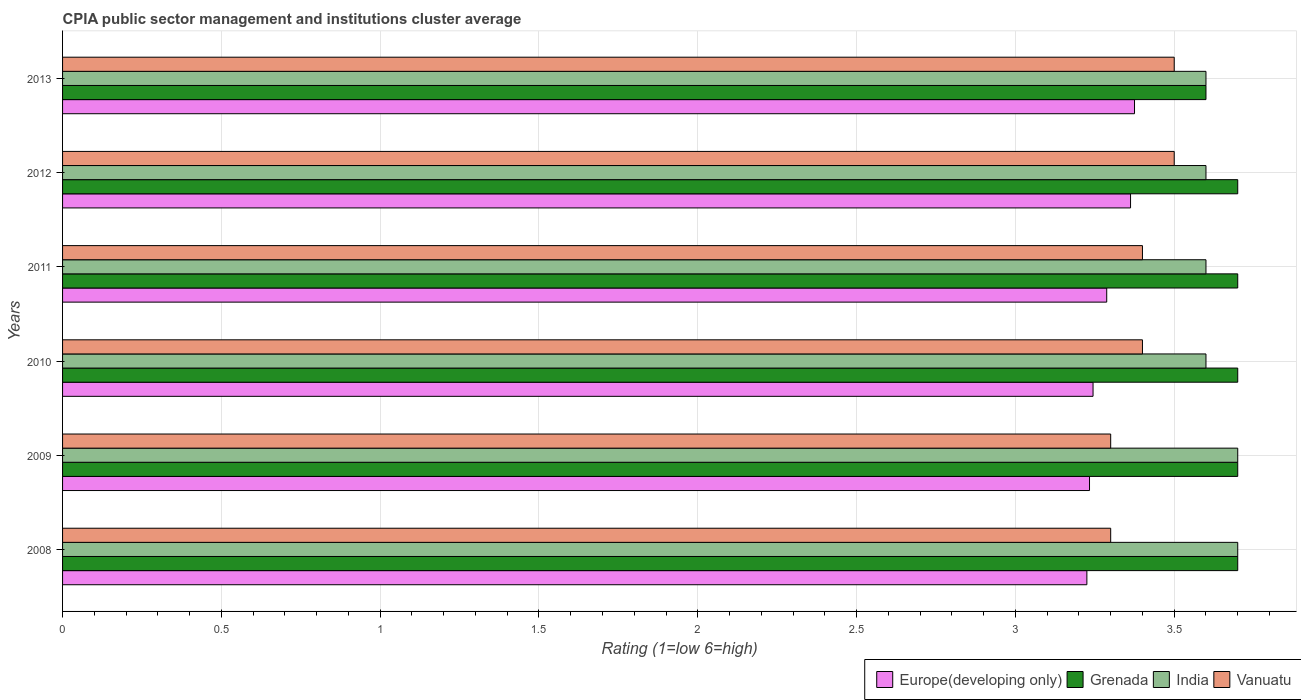How many bars are there on the 5th tick from the top?
Provide a short and direct response. 4. In how many cases, is the number of bars for a given year not equal to the number of legend labels?
Your response must be concise. 0. What is the CPIA rating in Europe(developing only) in 2009?
Make the answer very short. 3.23. What is the total CPIA rating in India in the graph?
Your response must be concise. 21.8. What is the difference between the CPIA rating in Vanuatu in 2012 and that in 2013?
Make the answer very short. 0. What is the difference between the CPIA rating in Vanuatu in 2011 and the CPIA rating in Europe(developing only) in 2012?
Your answer should be compact. 0.04. What is the average CPIA rating in Europe(developing only) per year?
Provide a short and direct response. 3.29. In the year 2011, what is the difference between the CPIA rating in Europe(developing only) and CPIA rating in Vanuatu?
Your answer should be very brief. -0.11. In how many years, is the CPIA rating in Europe(developing only) greater than 2.7 ?
Provide a succinct answer. 6. Is the difference between the CPIA rating in Europe(developing only) in 2008 and 2013 greater than the difference between the CPIA rating in Vanuatu in 2008 and 2013?
Offer a terse response. Yes. What is the difference between the highest and the lowest CPIA rating in Vanuatu?
Your response must be concise. 0.2. In how many years, is the CPIA rating in Grenada greater than the average CPIA rating in Grenada taken over all years?
Your answer should be compact. 5. Is the sum of the CPIA rating in India in 2008 and 2009 greater than the maximum CPIA rating in Europe(developing only) across all years?
Ensure brevity in your answer.  Yes. What does the 4th bar from the top in 2013 represents?
Keep it short and to the point. Europe(developing only). What does the 4th bar from the bottom in 2009 represents?
Make the answer very short. Vanuatu. Are all the bars in the graph horizontal?
Provide a succinct answer. Yes. Are the values on the major ticks of X-axis written in scientific E-notation?
Your response must be concise. No. Does the graph contain grids?
Offer a very short reply. Yes. How many legend labels are there?
Keep it short and to the point. 4. How are the legend labels stacked?
Ensure brevity in your answer.  Horizontal. What is the title of the graph?
Ensure brevity in your answer.  CPIA public sector management and institutions cluster average. Does "Netherlands" appear as one of the legend labels in the graph?
Make the answer very short. No. What is the label or title of the X-axis?
Your answer should be very brief. Rating (1=low 6=high). What is the label or title of the Y-axis?
Provide a short and direct response. Years. What is the Rating (1=low 6=high) of Europe(developing only) in 2008?
Your answer should be very brief. 3.23. What is the Rating (1=low 6=high) in Europe(developing only) in 2009?
Provide a succinct answer. 3.23. What is the Rating (1=low 6=high) of Grenada in 2009?
Keep it short and to the point. 3.7. What is the Rating (1=low 6=high) of Vanuatu in 2009?
Offer a terse response. 3.3. What is the Rating (1=low 6=high) in Europe(developing only) in 2010?
Offer a terse response. 3.24. What is the Rating (1=low 6=high) in India in 2010?
Your response must be concise. 3.6. What is the Rating (1=low 6=high) in Vanuatu in 2010?
Keep it short and to the point. 3.4. What is the Rating (1=low 6=high) in Europe(developing only) in 2011?
Ensure brevity in your answer.  3.29. What is the Rating (1=low 6=high) in Grenada in 2011?
Keep it short and to the point. 3.7. What is the Rating (1=low 6=high) in Europe(developing only) in 2012?
Your answer should be compact. 3.36. What is the Rating (1=low 6=high) of Vanuatu in 2012?
Your answer should be compact. 3.5. What is the Rating (1=low 6=high) in Europe(developing only) in 2013?
Offer a very short reply. 3.38. What is the Rating (1=low 6=high) of India in 2013?
Offer a terse response. 3.6. Across all years, what is the maximum Rating (1=low 6=high) of Europe(developing only)?
Provide a succinct answer. 3.38. Across all years, what is the minimum Rating (1=low 6=high) in Europe(developing only)?
Offer a very short reply. 3.23. What is the total Rating (1=low 6=high) of Europe(developing only) in the graph?
Keep it short and to the point. 19.73. What is the total Rating (1=low 6=high) in Grenada in the graph?
Keep it short and to the point. 22.1. What is the total Rating (1=low 6=high) in India in the graph?
Your answer should be compact. 21.8. What is the total Rating (1=low 6=high) in Vanuatu in the graph?
Provide a short and direct response. 20.4. What is the difference between the Rating (1=low 6=high) of Europe(developing only) in 2008 and that in 2009?
Keep it short and to the point. -0.01. What is the difference between the Rating (1=low 6=high) of Grenada in 2008 and that in 2009?
Your response must be concise. 0. What is the difference between the Rating (1=low 6=high) in India in 2008 and that in 2009?
Make the answer very short. 0. What is the difference between the Rating (1=low 6=high) of Europe(developing only) in 2008 and that in 2010?
Make the answer very short. -0.02. What is the difference between the Rating (1=low 6=high) in Grenada in 2008 and that in 2010?
Provide a succinct answer. 0. What is the difference between the Rating (1=low 6=high) in India in 2008 and that in 2010?
Make the answer very short. 0.1. What is the difference between the Rating (1=low 6=high) of Vanuatu in 2008 and that in 2010?
Offer a terse response. -0.1. What is the difference between the Rating (1=low 6=high) of Europe(developing only) in 2008 and that in 2011?
Ensure brevity in your answer.  -0.06. What is the difference between the Rating (1=low 6=high) in India in 2008 and that in 2011?
Your answer should be very brief. 0.1. What is the difference between the Rating (1=low 6=high) of Europe(developing only) in 2008 and that in 2012?
Keep it short and to the point. -0.14. What is the difference between the Rating (1=low 6=high) in Vanuatu in 2008 and that in 2012?
Keep it short and to the point. -0.2. What is the difference between the Rating (1=low 6=high) in Grenada in 2008 and that in 2013?
Keep it short and to the point. 0.1. What is the difference between the Rating (1=low 6=high) in India in 2008 and that in 2013?
Provide a succinct answer. 0.1. What is the difference between the Rating (1=low 6=high) in Vanuatu in 2008 and that in 2013?
Give a very brief answer. -0.2. What is the difference between the Rating (1=low 6=high) of Europe(developing only) in 2009 and that in 2010?
Offer a terse response. -0.01. What is the difference between the Rating (1=low 6=high) in Grenada in 2009 and that in 2010?
Offer a terse response. 0. What is the difference between the Rating (1=low 6=high) in India in 2009 and that in 2010?
Give a very brief answer. 0.1. What is the difference between the Rating (1=low 6=high) of Vanuatu in 2009 and that in 2010?
Give a very brief answer. -0.1. What is the difference between the Rating (1=low 6=high) in Europe(developing only) in 2009 and that in 2011?
Give a very brief answer. -0.05. What is the difference between the Rating (1=low 6=high) of Vanuatu in 2009 and that in 2011?
Make the answer very short. -0.1. What is the difference between the Rating (1=low 6=high) of Europe(developing only) in 2009 and that in 2012?
Offer a terse response. -0.13. What is the difference between the Rating (1=low 6=high) in Grenada in 2009 and that in 2012?
Offer a terse response. 0. What is the difference between the Rating (1=low 6=high) in India in 2009 and that in 2012?
Offer a terse response. 0.1. What is the difference between the Rating (1=low 6=high) in Europe(developing only) in 2009 and that in 2013?
Provide a short and direct response. -0.14. What is the difference between the Rating (1=low 6=high) in India in 2009 and that in 2013?
Provide a succinct answer. 0.1. What is the difference between the Rating (1=low 6=high) in Europe(developing only) in 2010 and that in 2011?
Give a very brief answer. -0.04. What is the difference between the Rating (1=low 6=high) in Grenada in 2010 and that in 2011?
Offer a very short reply. 0. What is the difference between the Rating (1=low 6=high) of Vanuatu in 2010 and that in 2011?
Keep it short and to the point. 0. What is the difference between the Rating (1=low 6=high) of Europe(developing only) in 2010 and that in 2012?
Provide a short and direct response. -0.12. What is the difference between the Rating (1=low 6=high) of Vanuatu in 2010 and that in 2012?
Your response must be concise. -0.1. What is the difference between the Rating (1=low 6=high) of Europe(developing only) in 2010 and that in 2013?
Offer a terse response. -0.13. What is the difference between the Rating (1=low 6=high) of Grenada in 2010 and that in 2013?
Provide a succinct answer. 0.1. What is the difference between the Rating (1=low 6=high) in India in 2010 and that in 2013?
Your answer should be compact. 0. What is the difference between the Rating (1=low 6=high) of Europe(developing only) in 2011 and that in 2012?
Make the answer very short. -0.07. What is the difference between the Rating (1=low 6=high) in Grenada in 2011 and that in 2012?
Ensure brevity in your answer.  0. What is the difference between the Rating (1=low 6=high) in India in 2011 and that in 2012?
Your answer should be compact. 0. What is the difference between the Rating (1=low 6=high) of Vanuatu in 2011 and that in 2012?
Ensure brevity in your answer.  -0.1. What is the difference between the Rating (1=low 6=high) of Europe(developing only) in 2011 and that in 2013?
Ensure brevity in your answer.  -0.09. What is the difference between the Rating (1=low 6=high) of Vanuatu in 2011 and that in 2013?
Your answer should be very brief. -0.1. What is the difference between the Rating (1=low 6=high) of Europe(developing only) in 2012 and that in 2013?
Ensure brevity in your answer.  -0.01. What is the difference between the Rating (1=low 6=high) in Grenada in 2012 and that in 2013?
Make the answer very short. 0.1. What is the difference between the Rating (1=low 6=high) in Vanuatu in 2012 and that in 2013?
Keep it short and to the point. 0. What is the difference between the Rating (1=low 6=high) of Europe(developing only) in 2008 and the Rating (1=low 6=high) of Grenada in 2009?
Offer a very short reply. -0.47. What is the difference between the Rating (1=low 6=high) in Europe(developing only) in 2008 and the Rating (1=low 6=high) in India in 2009?
Keep it short and to the point. -0.47. What is the difference between the Rating (1=low 6=high) of Europe(developing only) in 2008 and the Rating (1=low 6=high) of Vanuatu in 2009?
Give a very brief answer. -0.07. What is the difference between the Rating (1=low 6=high) in Grenada in 2008 and the Rating (1=low 6=high) in India in 2009?
Provide a short and direct response. 0. What is the difference between the Rating (1=low 6=high) in Europe(developing only) in 2008 and the Rating (1=low 6=high) in Grenada in 2010?
Ensure brevity in your answer.  -0.47. What is the difference between the Rating (1=low 6=high) in Europe(developing only) in 2008 and the Rating (1=low 6=high) in India in 2010?
Offer a very short reply. -0.38. What is the difference between the Rating (1=low 6=high) in Europe(developing only) in 2008 and the Rating (1=low 6=high) in Vanuatu in 2010?
Your response must be concise. -0.17. What is the difference between the Rating (1=low 6=high) of Grenada in 2008 and the Rating (1=low 6=high) of India in 2010?
Give a very brief answer. 0.1. What is the difference between the Rating (1=low 6=high) of Grenada in 2008 and the Rating (1=low 6=high) of Vanuatu in 2010?
Your answer should be very brief. 0.3. What is the difference between the Rating (1=low 6=high) of India in 2008 and the Rating (1=low 6=high) of Vanuatu in 2010?
Make the answer very short. 0.3. What is the difference between the Rating (1=low 6=high) of Europe(developing only) in 2008 and the Rating (1=low 6=high) of Grenada in 2011?
Provide a succinct answer. -0.47. What is the difference between the Rating (1=low 6=high) of Europe(developing only) in 2008 and the Rating (1=low 6=high) of India in 2011?
Provide a short and direct response. -0.38. What is the difference between the Rating (1=low 6=high) in Europe(developing only) in 2008 and the Rating (1=low 6=high) in Vanuatu in 2011?
Make the answer very short. -0.17. What is the difference between the Rating (1=low 6=high) in Grenada in 2008 and the Rating (1=low 6=high) in Vanuatu in 2011?
Give a very brief answer. 0.3. What is the difference between the Rating (1=low 6=high) in Europe(developing only) in 2008 and the Rating (1=low 6=high) in Grenada in 2012?
Offer a very short reply. -0.47. What is the difference between the Rating (1=low 6=high) in Europe(developing only) in 2008 and the Rating (1=low 6=high) in India in 2012?
Your answer should be compact. -0.38. What is the difference between the Rating (1=low 6=high) in Europe(developing only) in 2008 and the Rating (1=low 6=high) in Vanuatu in 2012?
Provide a succinct answer. -0.28. What is the difference between the Rating (1=low 6=high) in Grenada in 2008 and the Rating (1=low 6=high) in Vanuatu in 2012?
Offer a very short reply. 0.2. What is the difference between the Rating (1=low 6=high) in India in 2008 and the Rating (1=low 6=high) in Vanuatu in 2012?
Your answer should be very brief. 0.2. What is the difference between the Rating (1=low 6=high) of Europe(developing only) in 2008 and the Rating (1=low 6=high) of Grenada in 2013?
Your answer should be very brief. -0.38. What is the difference between the Rating (1=low 6=high) of Europe(developing only) in 2008 and the Rating (1=low 6=high) of India in 2013?
Your response must be concise. -0.38. What is the difference between the Rating (1=low 6=high) in Europe(developing only) in 2008 and the Rating (1=low 6=high) in Vanuatu in 2013?
Ensure brevity in your answer.  -0.28. What is the difference between the Rating (1=low 6=high) of Grenada in 2008 and the Rating (1=low 6=high) of India in 2013?
Provide a succinct answer. 0.1. What is the difference between the Rating (1=low 6=high) in Europe(developing only) in 2009 and the Rating (1=low 6=high) in Grenada in 2010?
Ensure brevity in your answer.  -0.47. What is the difference between the Rating (1=low 6=high) in Europe(developing only) in 2009 and the Rating (1=low 6=high) in India in 2010?
Your answer should be very brief. -0.37. What is the difference between the Rating (1=low 6=high) of Europe(developing only) in 2009 and the Rating (1=low 6=high) of Vanuatu in 2010?
Ensure brevity in your answer.  -0.17. What is the difference between the Rating (1=low 6=high) of Grenada in 2009 and the Rating (1=low 6=high) of India in 2010?
Offer a terse response. 0.1. What is the difference between the Rating (1=low 6=high) of India in 2009 and the Rating (1=low 6=high) of Vanuatu in 2010?
Offer a terse response. 0.3. What is the difference between the Rating (1=low 6=high) in Europe(developing only) in 2009 and the Rating (1=low 6=high) in Grenada in 2011?
Ensure brevity in your answer.  -0.47. What is the difference between the Rating (1=low 6=high) in Europe(developing only) in 2009 and the Rating (1=low 6=high) in India in 2011?
Keep it short and to the point. -0.37. What is the difference between the Rating (1=low 6=high) in Grenada in 2009 and the Rating (1=low 6=high) in Vanuatu in 2011?
Give a very brief answer. 0.3. What is the difference between the Rating (1=low 6=high) in India in 2009 and the Rating (1=low 6=high) in Vanuatu in 2011?
Make the answer very short. 0.3. What is the difference between the Rating (1=low 6=high) of Europe(developing only) in 2009 and the Rating (1=low 6=high) of Grenada in 2012?
Your answer should be very brief. -0.47. What is the difference between the Rating (1=low 6=high) of Europe(developing only) in 2009 and the Rating (1=low 6=high) of India in 2012?
Make the answer very short. -0.37. What is the difference between the Rating (1=low 6=high) in Europe(developing only) in 2009 and the Rating (1=low 6=high) in Vanuatu in 2012?
Keep it short and to the point. -0.27. What is the difference between the Rating (1=low 6=high) of Grenada in 2009 and the Rating (1=low 6=high) of India in 2012?
Keep it short and to the point. 0.1. What is the difference between the Rating (1=low 6=high) in Europe(developing only) in 2009 and the Rating (1=low 6=high) in Grenada in 2013?
Your answer should be very brief. -0.37. What is the difference between the Rating (1=low 6=high) in Europe(developing only) in 2009 and the Rating (1=low 6=high) in India in 2013?
Your response must be concise. -0.37. What is the difference between the Rating (1=low 6=high) of Europe(developing only) in 2009 and the Rating (1=low 6=high) of Vanuatu in 2013?
Offer a very short reply. -0.27. What is the difference between the Rating (1=low 6=high) of Grenada in 2009 and the Rating (1=low 6=high) of India in 2013?
Offer a very short reply. 0.1. What is the difference between the Rating (1=low 6=high) of Grenada in 2009 and the Rating (1=low 6=high) of Vanuatu in 2013?
Your response must be concise. 0.2. What is the difference between the Rating (1=low 6=high) in India in 2009 and the Rating (1=low 6=high) in Vanuatu in 2013?
Keep it short and to the point. 0.2. What is the difference between the Rating (1=low 6=high) in Europe(developing only) in 2010 and the Rating (1=low 6=high) in Grenada in 2011?
Keep it short and to the point. -0.46. What is the difference between the Rating (1=low 6=high) in Europe(developing only) in 2010 and the Rating (1=low 6=high) in India in 2011?
Offer a terse response. -0.36. What is the difference between the Rating (1=low 6=high) of Europe(developing only) in 2010 and the Rating (1=low 6=high) of Vanuatu in 2011?
Ensure brevity in your answer.  -0.16. What is the difference between the Rating (1=low 6=high) in Europe(developing only) in 2010 and the Rating (1=low 6=high) in Grenada in 2012?
Give a very brief answer. -0.46. What is the difference between the Rating (1=low 6=high) of Europe(developing only) in 2010 and the Rating (1=low 6=high) of India in 2012?
Make the answer very short. -0.36. What is the difference between the Rating (1=low 6=high) of Europe(developing only) in 2010 and the Rating (1=low 6=high) of Vanuatu in 2012?
Ensure brevity in your answer.  -0.26. What is the difference between the Rating (1=low 6=high) in Grenada in 2010 and the Rating (1=low 6=high) in India in 2012?
Provide a short and direct response. 0.1. What is the difference between the Rating (1=low 6=high) in Grenada in 2010 and the Rating (1=low 6=high) in Vanuatu in 2012?
Give a very brief answer. 0.2. What is the difference between the Rating (1=low 6=high) in India in 2010 and the Rating (1=low 6=high) in Vanuatu in 2012?
Give a very brief answer. 0.1. What is the difference between the Rating (1=low 6=high) of Europe(developing only) in 2010 and the Rating (1=low 6=high) of Grenada in 2013?
Ensure brevity in your answer.  -0.36. What is the difference between the Rating (1=low 6=high) in Europe(developing only) in 2010 and the Rating (1=low 6=high) in India in 2013?
Ensure brevity in your answer.  -0.36. What is the difference between the Rating (1=low 6=high) in Europe(developing only) in 2010 and the Rating (1=low 6=high) in Vanuatu in 2013?
Offer a terse response. -0.26. What is the difference between the Rating (1=low 6=high) in Grenada in 2010 and the Rating (1=low 6=high) in India in 2013?
Offer a terse response. 0.1. What is the difference between the Rating (1=low 6=high) in India in 2010 and the Rating (1=low 6=high) in Vanuatu in 2013?
Your answer should be very brief. 0.1. What is the difference between the Rating (1=low 6=high) in Europe(developing only) in 2011 and the Rating (1=low 6=high) in Grenada in 2012?
Offer a very short reply. -0.41. What is the difference between the Rating (1=low 6=high) in Europe(developing only) in 2011 and the Rating (1=low 6=high) in India in 2012?
Offer a very short reply. -0.31. What is the difference between the Rating (1=low 6=high) of Europe(developing only) in 2011 and the Rating (1=low 6=high) of Vanuatu in 2012?
Ensure brevity in your answer.  -0.21. What is the difference between the Rating (1=low 6=high) of Grenada in 2011 and the Rating (1=low 6=high) of India in 2012?
Make the answer very short. 0.1. What is the difference between the Rating (1=low 6=high) in Grenada in 2011 and the Rating (1=low 6=high) in Vanuatu in 2012?
Provide a succinct answer. 0.2. What is the difference between the Rating (1=low 6=high) in Europe(developing only) in 2011 and the Rating (1=low 6=high) in Grenada in 2013?
Give a very brief answer. -0.31. What is the difference between the Rating (1=low 6=high) of Europe(developing only) in 2011 and the Rating (1=low 6=high) of India in 2013?
Make the answer very short. -0.31. What is the difference between the Rating (1=low 6=high) in Europe(developing only) in 2011 and the Rating (1=low 6=high) in Vanuatu in 2013?
Offer a very short reply. -0.21. What is the difference between the Rating (1=low 6=high) of Grenada in 2011 and the Rating (1=low 6=high) of India in 2013?
Provide a succinct answer. 0.1. What is the difference between the Rating (1=low 6=high) in Europe(developing only) in 2012 and the Rating (1=low 6=high) in Grenada in 2013?
Give a very brief answer. -0.24. What is the difference between the Rating (1=low 6=high) in Europe(developing only) in 2012 and the Rating (1=low 6=high) in India in 2013?
Offer a very short reply. -0.24. What is the difference between the Rating (1=low 6=high) of Europe(developing only) in 2012 and the Rating (1=low 6=high) of Vanuatu in 2013?
Offer a very short reply. -0.14. What is the average Rating (1=low 6=high) in Europe(developing only) per year?
Your answer should be compact. 3.29. What is the average Rating (1=low 6=high) in Grenada per year?
Offer a terse response. 3.68. What is the average Rating (1=low 6=high) in India per year?
Ensure brevity in your answer.  3.63. In the year 2008, what is the difference between the Rating (1=low 6=high) of Europe(developing only) and Rating (1=low 6=high) of Grenada?
Give a very brief answer. -0.47. In the year 2008, what is the difference between the Rating (1=low 6=high) in Europe(developing only) and Rating (1=low 6=high) in India?
Keep it short and to the point. -0.47. In the year 2008, what is the difference between the Rating (1=low 6=high) in Europe(developing only) and Rating (1=low 6=high) in Vanuatu?
Offer a terse response. -0.07. In the year 2008, what is the difference between the Rating (1=low 6=high) of Grenada and Rating (1=low 6=high) of India?
Provide a short and direct response. 0. In the year 2008, what is the difference between the Rating (1=low 6=high) in Grenada and Rating (1=low 6=high) in Vanuatu?
Provide a succinct answer. 0.4. In the year 2008, what is the difference between the Rating (1=low 6=high) in India and Rating (1=low 6=high) in Vanuatu?
Offer a very short reply. 0.4. In the year 2009, what is the difference between the Rating (1=low 6=high) in Europe(developing only) and Rating (1=low 6=high) in Grenada?
Ensure brevity in your answer.  -0.47. In the year 2009, what is the difference between the Rating (1=low 6=high) of Europe(developing only) and Rating (1=low 6=high) of India?
Offer a terse response. -0.47. In the year 2009, what is the difference between the Rating (1=low 6=high) in Europe(developing only) and Rating (1=low 6=high) in Vanuatu?
Offer a terse response. -0.07. In the year 2009, what is the difference between the Rating (1=low 6=high) of Grenada and Rating (1=low 6=high) of Vanuatu?
Make the answer very short. 0.4. In the year 2010, what is the difference between the Rating (1=low 6=high) in Europe(developing only) and Rating (1=low 6=high) in Grenada?
Provide a succinct answer. -0.46. In the year 2010, what is the difference between the Rating (1=low 6=high) of Europe(developing only) and Rating (1=low 6=high) of India?
Keep it short and to the point. -0.36. In the year 2010, what is the difference between the Rating (1=low 6=high) of Europe(developing only) and Rating (1=low 6=high) of Vanuatu?
Provide a short and direct response. -0.16. In the year 2010, what is the difference between the Rating (1=low 6=high) of Grenada and Rating (1=low 6=high) of India?
Provide a short and direct response. 0.1. In the year 2010, what is the difference between the Rating (1=low 6=high) in Grenada and Rating (1=low 6=high) in Vanuatu?
Your answer should be very brief. 0.3. In the year 2010, what is the difference between the Rating (1=low 6=high) in India and Rating (1=low 6=high) in Vanuatu?
Make the answer very short. 0.2. In the year 2011, what is the difference between the Rating (1=low 6=high) in Europe(developing only) and Rating (1=low 6=high) in Grenada?
Your response must be concise. -0.41. In the year 2011, what is the difference between the Rating (1=low 6=high) of Europe(developing only) and Rating (1=low 6=high) of India?
Provide a succinct answer. -0.31. In the year 2011, what is the difference between the Rating (1=low 6=high) of Europe(developing only) and Rating (1=low 6=high) of Vanuatu?
Offer a very short reply. -0.11. In the year 2011, what is the difference between the Rating (1=low 6=high) in Grenada and Rating (1=low 6=high) in Vanuatu?
Your answer should be compact. 0.3. In the year 2012, what is the difference between the Rating (1=low 6=high) in Europe(developing only) and Rating (1=low 6=high) in Grenada?
Provide a short and direct response. -0.34. In the year 2012, what is the difference between the Rating (1=low 6=high) in Europe(developing only) and Rating (1=low 6=high) in India?
Offer a terse response. -0.24. In the year 2012, what is the difference between the Rating (1=low 6=high) of Europe(developing only) and Rating (1=low 6=high) of Vanuatu?
Your response must be concise. -0.14. In the year 2012, what is the difference between the Rating (1=low 6=high) of Grenada and Rating (1=low 6=high) of India?
Your response must be concise. 0.1. In the year 2012, what is the difference between the Rating (1=low 6=high) in India and Rating (1=low 6=high) in Vanuatu?
Offer a very short reply. 0.1. In the year 2013, what is the difference between the Rating (1=low 6=high) in Europe(developing only) and Rating (1=low 6=high) in Grenada?
Keep it short and to the point. -0.23. In the year 2013, what is the difference between the Rating (1=low 6=high) in Europe(developing only) and Rating (1=low 6=high) in India?
Ensure brevity in your answer.  -0.23. In the year 2013, what is the difference between the Rating (1=low 6=high) in Europe(developing only) and Rating (1=low 6=high) in Vanuatu?
Ensure brevity in your answer.  -0.12. In the year 2013, what is the difference between the Rating (1=low 6=high) in Grenada and Rating (1=low 6=high) in Vanuatu?
Offer a very short reply. 0.1. In the year 2013, what is the difference between the Rating (1=low 6=high) of India and Rating (1=low 6=high) of Vanuatu?
Provide a short and direct response. 0.1. What is the ratio of the Rating (1=low 6=high) of Europe(developing only) in 2008 to that in 2009?
Provide a short and direct response. 1. What is the ratio of the Rating (1=low 6=high) in India in 2008 to that in 2009?
Offer a very short reply. 1. What is the ratio of the Rating (1=low 6=high) of Vanuatu in 2008 to that in 2009?
Your answer should be very brief. 1. What is the ratio of the Rating (1=low 6=high) of Europe(developing only) in 2008 to that in 2010?
Offer a terse response. 0.99. What is the ratio of the Rating (1=low 6=high) of India in 2008 to that in 2010?
Keep it short and to the point. 1.03. What is the ratio of the Rating (1=low 6=high) in Vanuatu in 2008 to that in 2010?
Provide a succinct answer. 0.97. What is the ratio of the Rating (1=low 6=high) of Europe(developing only) in 2008 to that in 2011?
Give a very brief answer. 0.98. What is the ratio of the Rating (1=low 6=high) in Grenada in 2008 to that in 2011?
Provide a short and direct response. 1. What is the ratio of the Rating (1=low 6=high) of India in 2008 to that in 2011?
Provide a short and direct response. 1.03. What is the ratio of the Rating (1=low 6=high) in Vanuatu in 2008 to that in 2011?
Ensure brevity in your answer.  0.97. What is the ratio of the Rating (1=low 6=high) of Europe(developing only) in 2008 to that in 2012?
Give a very brief answer. 0.96. What is the ratio of the Rating (1=low 6=high) of India in 2008 to that in 2012?
Your answer should be compact. 1.03. What is the ratio of the Rating (1=low 6=high) in Vanuatu in 2008 to that in 2012?
Your response must be concise. 0.94. What is the ratio of the Rating (1=low 6=high) in Europe(developing only) in 2008 to that in 2013?
Your answer should be compact. 0.96. What is the ratio of the Rating (1=low 6=high) of Grenada in 2008 to that in 2013?
Provide a short and direct response. 1.03. What is the ratio of the Rating (1=low 6=high) of India in 2008 to that in 2013?
Offer a terse response. 1.03. What is the ratio of the Rating (1=low 6=high) of Vanuatu in 2008 to that in 2013?
Give a very brief answer. 0.94. What is the ratio of the Rating (1=low 6=high) of Europe(developing only) in 2009 to that in 2010?
Ensure brevity in your answer.  1. What is the ratio of the Rating (1=low 6=high) in India in 2009 to that in 2010?
Keep it short and to the point. 1.03. What is the ratio of the Rating (1=low 6=high) of Vanuatu in 2009 to that in 2010?
Your answer should be very brief. 0.97. What is the ratio of the Rating (1=low 6=high) of Europe(developing only) in 2009 to that in 2011?
Your answer should be very brief. 0.98. What is the ratio of the Rating (1=low 6=high) in Grenada in 2009 to that in 2011?
Ensure brevity in your answer.  1. What is the ratio of the Rating (1=low 6=high) in India in 2009 to that in 2011?
Offer a very short reply. 1.03. What is the ratio of the Rating (1=low 6=high) of Vanuatu in 2009 to that in 2011?
Keep it short and to the point. 0.97. What is the ratio of the Rating (1=low 6=high) in Europe(developing only) in 2009 to that in 2012?
Your answer should be very brief. 0.96. What is the ratio of the Rating (1=low 6=high) of India in 2009 to that in 2012?
Your response must be concise. 1.03. What is the ratio of the Rating (1=low 6=high) of Vanuatu in 2009 to that in 2012?
Your answer should be very brief. 0.94. What is the ratio of the Rating (1=low 6=high) of Europe(developing only) in 2009 to that in 2013?
Offer a very short reply. 0.96. What is the ratio of the Rating (1=low 6=high) of Grenada in 2009 to that in 2013?
Provide a short and direct response. 1.03. What is the ratio of the Rating (1=low 6=high) of India in 2009 to that in 2013?
Give a very brief answer. 1.03. What is the ratio of the Rating (1=low 6=high) of Vanuatu in 2009 to that in 2013?
Provide a succinct answer. 0.94. What is the ratio of the Rating (1=low 6=high) in Europe(developing only) in 2010 to that in 2011?
Provide a short and direct response. 0.99. What is the ratio of the Rating (1=low 6=high) of Vanuatu in 2010 to that in 2011?
Make the answer very short. 1. What is the ratio of the Rating (1=low 6=high) in Europe(developing only) in 2010 to that in 2012?
Offer a terse response. 0.96. What is the ratio of the Rating (1=low 6=high) in India in 2010 to that in 2012?
Offer a terse response. 1. What is the ratio of the Rating (1=low 6=high) of Vanuatu in 2010 to that in 2012?
Your response must be concise. 0.97. What is the ratio of the Rating (1=low 6=high) of Europe(developing only) in 2010 to that in 2013?
Offer a terse response. 0.96. What is the ratio of the Rating (1=low 6=high) in Grenada in 2010 to that in 2013?
Keep it short and to the point. 1.03. What is the ratio of the Rating (1=low 6=high) of India in 2010 to that in 2013?
Your answer should be compact. 1. What is the ratio of the Rating (1=low 6=high) in Vanuatu in 2010 to that in 2013?
Your answer should be compact. 0.97. What is the ratio of the Rating (1=low 6=high) in Europe(developing only) in 2011 to that in 2012?
Provide a succinct answer. 0.98. What is the ratio of the Rating (1=low 6=high) of India in 2011 to that in 2012?
Provide a succinct answer. 1. What is the ratio of the Rating (1=low 6=high) of Vanuatu in 2011 to that in 2012?
Ensure brevity in your answer.  0.97. What is the ratio of the Rating (1=low 6=high) in Europe(developing only) in 2011 to that in 2013?
Give a very brief answer. 0.97. What is the ratio of the Rating (1=low 6=high) of Grenada in 2011 to that in 2013?
Ensure brevity in your answer.  1.03. What is the ratio of the Rating (1=low 6=high) of Vanuatu in 2011 to that in 2013?
Your answer should be compact. 0.97. What is the ratio of the Rating (1=low 6=high) in Grenada in 2012 to that in 2013?
Give a very brief answer. 1.03. What is the ratio of the Rating (1=low 6=high) in India in 2012 to that in 2013?
Provide a succinct answer. 1. What is the ratio of the Rating (1=low 6=high) in Vanuatu in 2012 to that in 2013?
Offer a terse response. 1. What is the difference between the highest and the second highest Rating (1=low 6=high) in Europe(developing only)?
Provide a succinct answer. 0.01. What is the difference between the highest and the second highest Rating (1=low 6=high) of Grenada?
Provide a succinct answer. 0. What is the difference between the highest and the second highest Rating (1=low 6=high) of India?
Your response must be concise. 0. What is the difference between the highest and the second highest Rating (1=low 6=high) in Vanuatu?
Offer a very short reply. 0. What is the difference between the highest and the lowest Rating (1=low 6=high) in India?
Give a very brief answer. 0.1. 